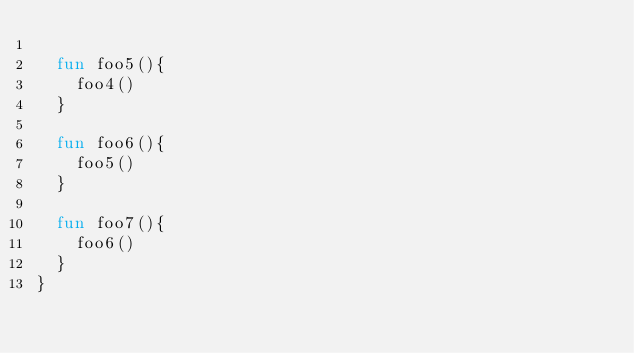Convert code to text. <code><loc_0><loc_0><loc_500><loc_500><_Kotlin_>
  fun foo5(){
    foo4()
  }

  fun foo6(){
    foo5()
  }

  fun foo7(){
    foo6()
  }
}</code> 